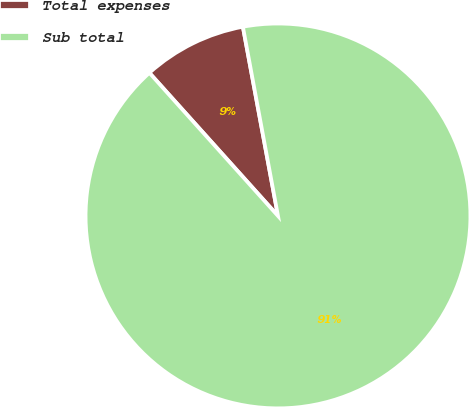Convert chart. <chart><loc_0><loc_0><loc_500><loc_500><pie_chart><fcel>Total expenses<fcel>Sub total<nl><fcel>8.73%<fcel>91.27%<nl></chart> 